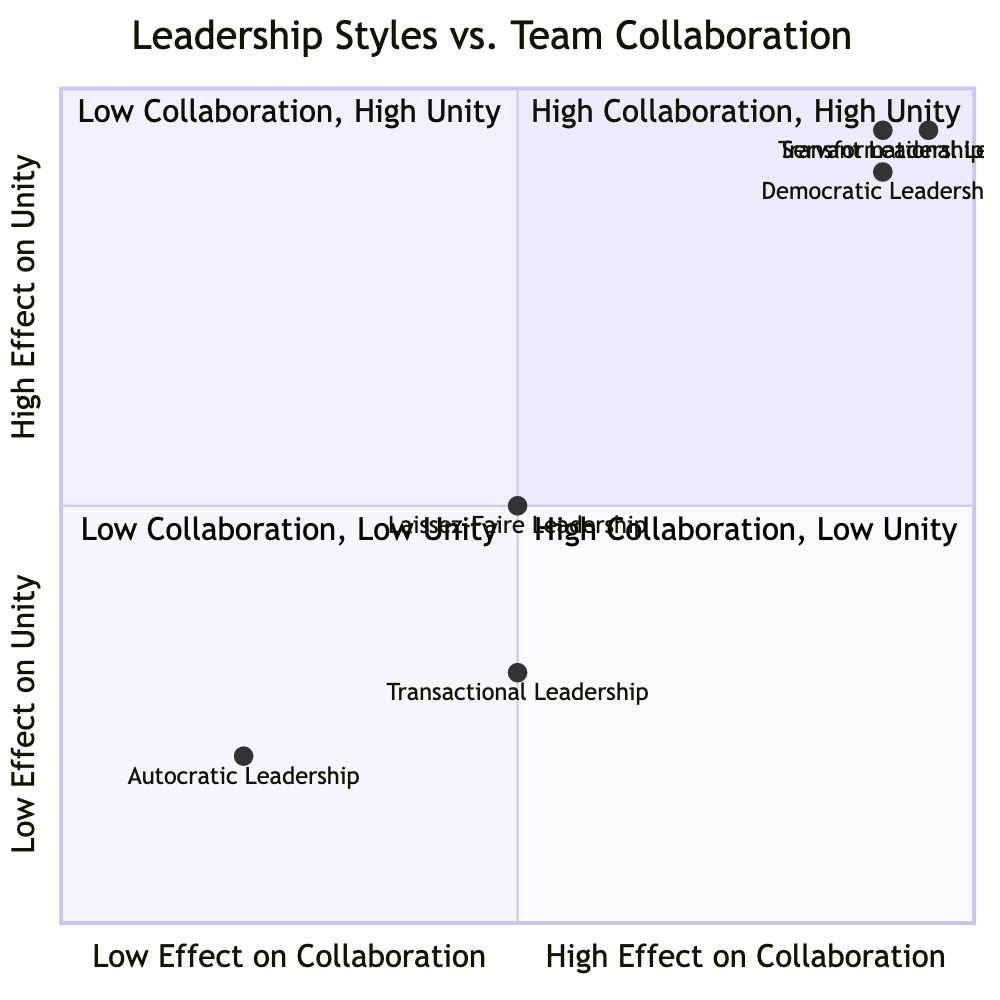What quadrant does Democratic Leadership fall into? The Democratic Leadership is positioned at coordinates [0.9, 0.9] on the quadrant chart. Both its effect on collaboration and unity are high, which places it in quadrant 1 where high collaboration and high unity are represented.
Answer: Quadrant 1 What is the effect on unity for Autocratic Leadership? The Autocratic Leadership's position is [0.2, 0.2] on the chart. The y-coordinate represents the effect on unity, which is low (0.2).
Answer: Low Which leadership style has the highest effect on collaboration? By comparing the x-coordinates of all leadership styles, Transformational Leadership is the highest at 0.95, which indicates the greatest effect on collaboration.
Answer: Transformational Leadership What are the effects on collaboration and unity for Servant Leadership? Servant Leadership is located at [0.9, 0.95]. The x-coordinate (0.9) represents high collaboration, while the y-coordinate (0.95) represents high unity.
Answer: High Collaboration, High Unity How many leadership styles have low effects on both collaboration and unity? The chart shows Autocratic Leadership in quadrant 3 with coordinates [0.2, 0.2], and Transactional Leadership in quadrant 4 with coordinates [0.5, 0.3]. Only Autocratic Leadership falls into the category of low effects on both metrics.
Answer: 1 Which leadership styles have high effects on both collaboration and unity? In reviewing the chart, the styles in quadrant 1 are Democratic Leadership, Transformational Leadership, and Servant Leadership, all of which have high collaboration and unity effects.
Answer: Democratic Leadership, Transformational Leadership, Servant Leadership What is the impact on collaboration for Transactional Leadership? The Transactional Leadership's position is [0.5, 0.3]. The x-coordinate (0.5) indicates a medium effect on collaboration.
Answer: Medium Which leadership style is hands-off and promotes independence? The Laissez-Faire Leadership style is characterized as hands-off, allowing group members to work independently, as indicated by its position on the chart at [0.5, 0.5].
Answer: Laissez-Faire Leadership What is the combined effect on unity of Transactional Leadership and Autocratic Leadership? Autocratic Leadership has an effect on unity of low (0.2) and Transactional Leadership has a low effect (0.3). The combined effect remains low since both styles are in adverse areas of the chart.
Answer: Low 